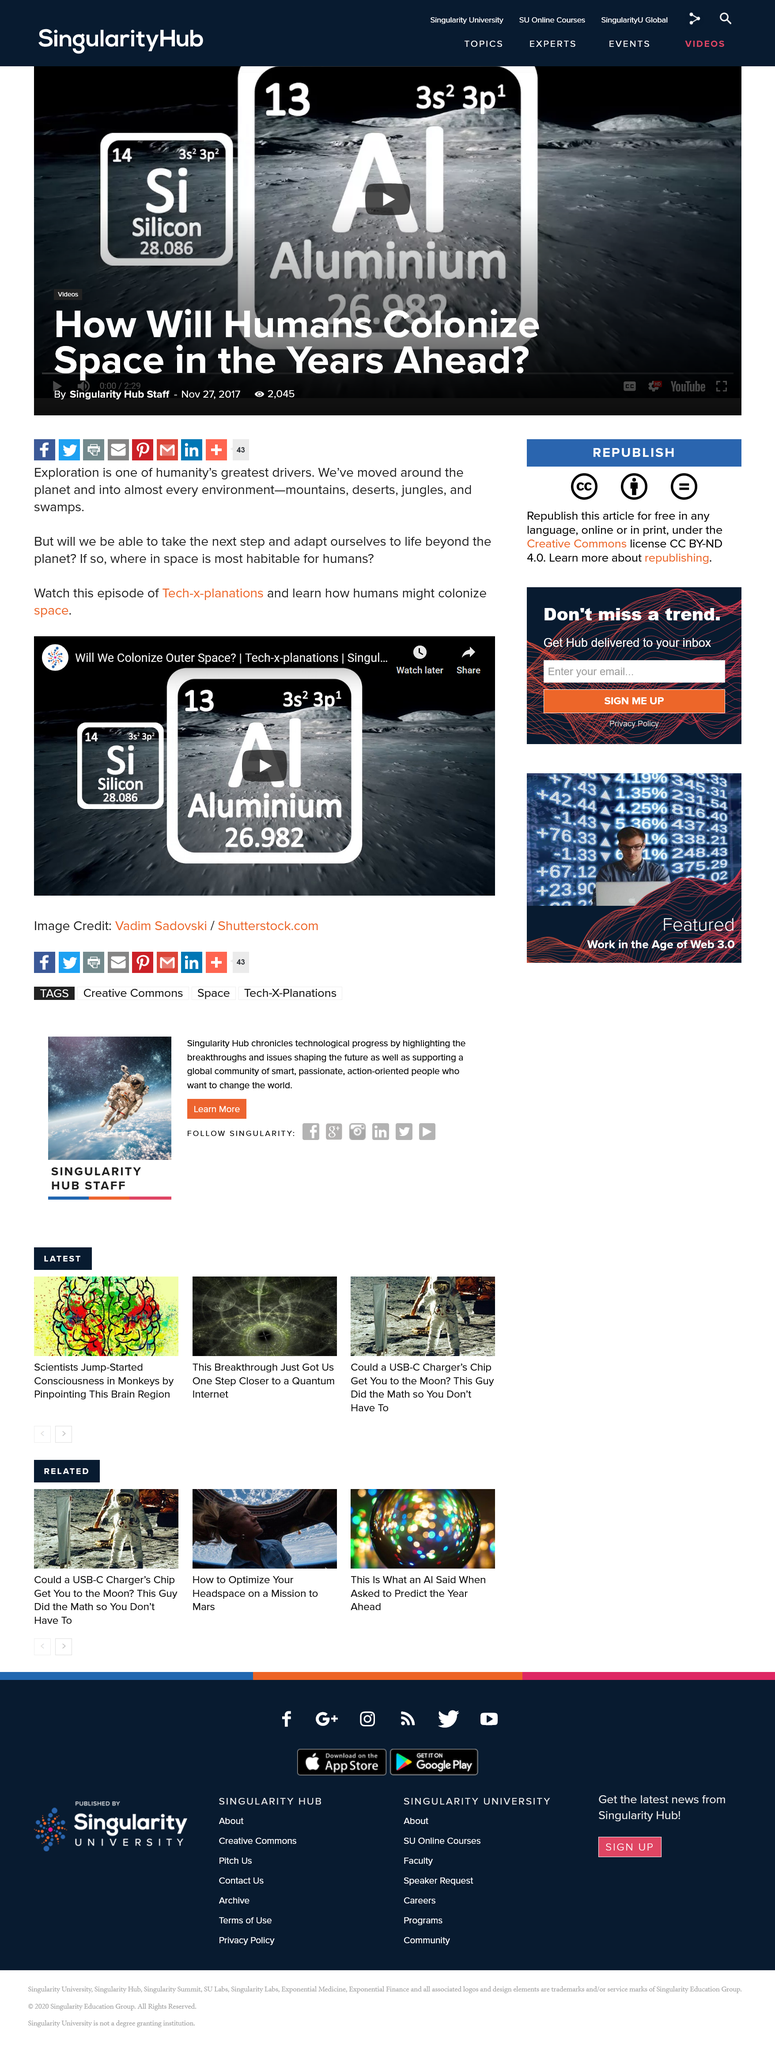Draw attention to some important aspects in this diagram. The atomic number for aluminum is 13. Aluminium is the chemical symbol for an element that is a silvery-white metal with the atomic number 13. It is a lightweight and durable material that is commonly used in a variety of applications, including construction, transportation, and packaging. The name "aluminium" is derived from the Latin word "alumen," meaning "poor man's silver," because the metal was initially believed to be a poor man's version of silver. Silicon is a chemical element represented by the symbol Si. It is a metalloid that is commonly found in sand and quartz. Silicon is used in a variety of industries, including electronics, construction, and chemical production. It is known for its strength, durability, and ability to withstand extreme temperatures, making it an important component in the production of semiconductors and other electronic devices. 